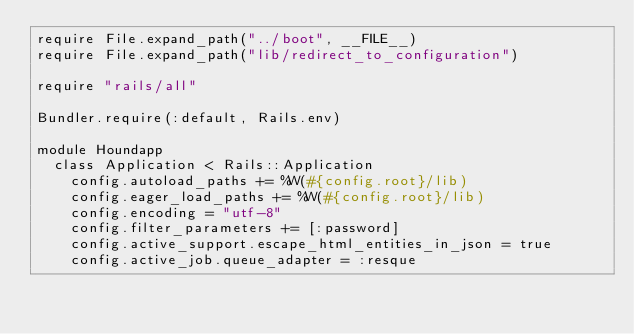Convert code to text. <code><loc_0><loc_0><loc_500><loc_500><_Ruby_>require File.expand_path("../boot", __FILE__)
require File.expand_path("lib/redirect_to_configuration")

require "rails/all"

Bundler.require(:default, Rails.env)

module Houndapp
  class Application < Rails::Application
    config.autoload_paths += %W(#{config.root}/lib)
    config.eager_load_paths += %W(#{config.root}/lib)
    config.encoding = "utf-8"
    config.filter_parameters += [:password]
    config.active_support.escape_html_entities_in_json = true
    config.active_job.queue_adapter = :resque</code> 